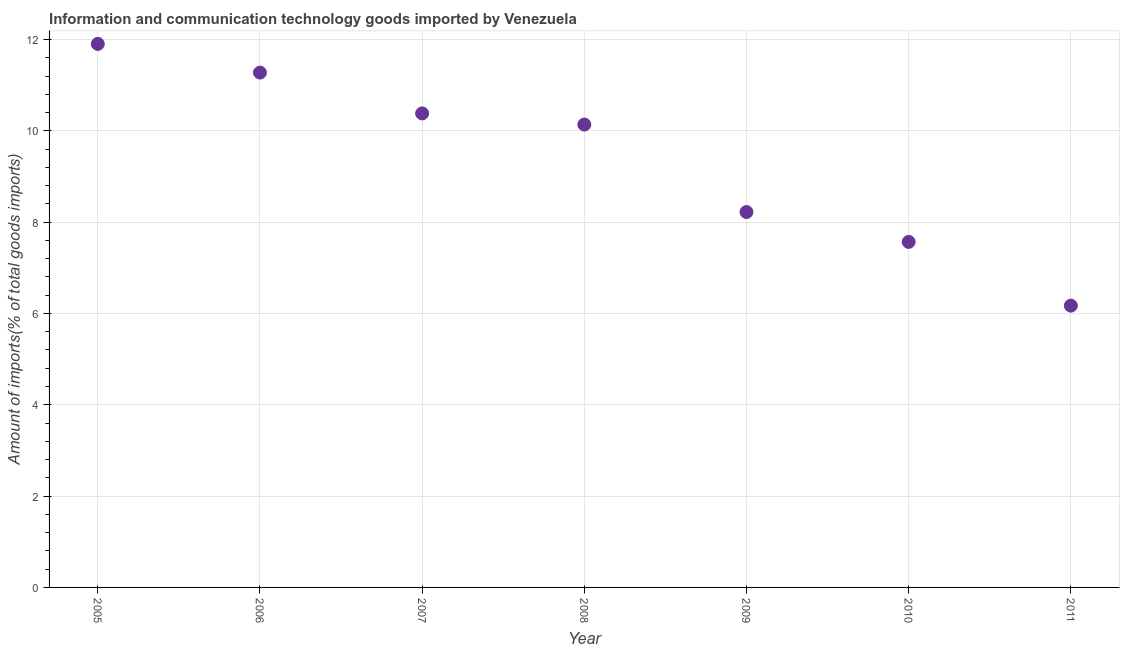What is the amount of ict goods imports in 2011?
Your answer should be compact. 6.17. Across all years, what is the maximum amount of ict goods imports?
Provide a short and direct response. 11.9. Across all years, what is the minimum amount of ict goods imports?
Make the answer very short. 6.17. In which year was the amount of ict goods imports minimum?
Make the answer very short. 2011. What is the sum of the amount of ict goods imports?
Offer a terse response. 65.66. What is the difference between the amount of ict goods imports in 2009 and 2010?
Ensure brevity in your answer.  0.65. What is the average amount of ict goods imports per year?
Offer a terse response. 9.38. What is the median amount of ict goods imports?
Provide a short and direct response. 10.14. In how many years, is the amount of ict goods imports greater than 9.2 %?
Ensure brevity in your answer.  4. Do a majority of the years between 2006 and 2008 (inclusive) have amount of ict goods imports greater than 2.4 %?
Provide a succinct answer. Yes. What is the ratio of the amount of ict goods imports in 2008 to that in 2010?
Offer a very short reply. 1.34. Is the amount of ict goods imports in 2007 less than that in 2010?
Provide a succinct answer. No. What is the difference between the highest and the second highest amount of ict goods imports?
Give a very brief answer. 0.63. What is the difference between the highest and the lowest amount of ict goods imports?
Offer a terse response. 5.73. How many dotlines are there?
Provide a short and direct response. 1. What is the difference between two consecutive major ticks on the Y-axis?
Keep it short and to the point. 2. Does the graph contain any zero values?
Provide a succinct answer. No. What is the title of the graph?
Your answer should be compact. Information and communication technology goods imported by Venezuela. What is the label or title of the Y-axis?
Keep it short and to the point. Amount of imports(% of total goods imports). What is the Amount of imports(% of total goods imports) in 2005?
Offer a terse response. 11.9. What is the Amount of imports(% of total goods imports) in 2006?
Offer a very short reply. 11.28. What is the Amount of imports(% of total goods imports) in 2007?
Your answer should be very brief. 10.38. What is the Amount of imports(% of total goods imports) in 2008?
Your answer should be very brief. 10.14. What is the Amount of imports(% of total goods imports) in 2009?
Offer a terse response. 8.22. What is the Amount of imports(% of total goods imports) in 2010?
Your answer should be very brief. 7.57. What is the Amount of imports(% of total goods imports) in 2011?
Offer a terse response. 6.17. What is the difference between the Amount of imports(% of total goods imports) in 2005 and 2006?
Provide a succinct answer. 0.63. What is the difference between the Amount of imports(% of total goods imports) in 2005 and 2007?
Provide a succinct answer. 1.52. What is the difference between the Amount of imports(% of total goods imports) in 2005 and 2008?
Give a very brief answer. 1.77. What is the difference between the Amount of imports(% of total goods imports) in 2005 and 2009?
Offer a very short reply. 3.68. What is the difference between the Amount of imports(% of total goods imports) in 2005 and 2010?
Your response must be concise. 4.34. What is the difference between the Amount of imports(% of total goods imports) in 2005 and 2011?
Your answer should be very brief. 5.73. What is the difference between the Amount of imports(% of total goods imports) in 2006 and 2007?
Your response must be concise. 0.89. What is the difference between the Amount of imports(% of total goods imports) in 2006 and 2008?
Ensure brevity in your answer.  1.14. What is the difference between the Amount of imports(% of total goods imports) in 2006 and 2009?
Ensure brevity in your answer.  3.05. What is the difference between the Amount of imports(% of total goods imports) in 2006 and 2010?
Offer a terse response. 3.71. What is the difference between the Amount of imports(% of total goods imports) in 2006 and 2011?
Keep it short and to the point. 5.1. What is the difference between the Amount of imports(% of total goods imports) in 2007 and 2008?
Provide a succinct answer. 0.24. What is the difference between the Amount of imports(% of total goods imports) in 2007 and 2009?
Offer a very short reply. 2.16. What is the difference between the Amount of imports(% of total goods imports) in 2007 and 2010?
Your answer should be compact. 2.81. What is the difference between the Amount of imports(% of total goods imports) in 2007 and 2011?
Your answer should be very brief. 4.21. What is the difference between the Amount of imports(% of total goods imports) in 2008 and 2009?
Provide a short and direct response. 1.92. What is the difference between the Amount of imports(% of total goods imports) in 2008 and 2010?
Give a very brief answer. 2.57. What is the difference between the Amount of imports(% of total goods imports) in 2008 and 2011?
Your answer should be compact. 3.97. What is the difference between the Amount of imports(% of total goods imports) in 2009 and 2010?
Provide a succinct answer. 0.65. What is the difference between the Amount of imports(% of total goods imports) in 2009 and 2011?
Your answer should be compact. 2.05. What is the difference between the Amount of imports(% of total goods imports) in 2010 and 2011?
Offer a terse response. 1.4. What is the ratio of the Amount of imports(% of total goods imports) in 2005 to that in 2006?
Provide a short and direct response. 1.06. What is the ratio of the Amount of imports(% of total goods imports) in 2005 to that in 2007?
Give a very brief answer. 1.15. What is the ratio of the Amount of imports(% of total goods imports) in 2005 to that in 2008?
Your answer should be very brief. 1.17. What is the ratio of the Amount of imports(% of total goods imports) in 2005 to that in 2009?
Your answer should be compact. 1.45. What is the ratio of the Amount of imports(% of total goods imports) in 2005 to that in 2010?
Your answer should be very brief. 1.57. What is the ratio of the Amount of imports(% of total goods imports) in 2005 to that in 2011?
Ensure brevity in your answer.  1.93. What is the ratio of the Amount of imports(% of total goods imports) in 2006 to that in 2007?
Offer a terse response. 1.09. What is the ratio of the Amount of imports(% of total goods imports) in 2006 to that in 2008?
Provide a succinct answer. 1.11. What is the ratio of the Amount of imports(% of total goods imports) in 2006 to that in 2009?
Give a very brief answer. 1.37. What is the ratio of the Amount of imports(% of total goods imports) in 2006 to that in 2010?
Offer a terse response. 1.49. What is the ratio of the Amount of imports(% of total goods imports) in 2006 to that in 2011?
Keep it short and to the point. 1.83. What is the ratio of the Amount of imports(% of total goods imports) in 2007 to that in 2009?
Make the answer very short. 1.26. What is the ratio of the Amount of imports(% of total goods imports) in 2007 to that in 2010?
Offer a terse response. 1.37. What is the ratio of the Amount of imports(% of total goods imports) in 2007 to that in 2011?
Offer a very short reply. 1.68. What is the ratio of the Amount of imports(% of total goods imports) in 2008 to that in 2009?
Your answer should be compact. 1.23. What is the ratio of the Amount of imports(% of total goods imports) in 2008 to that in 2010?
Provide a short and direct response. 1.34. What is the ratio of the Amount of imports(% of total goods imports) in 2008 to that in 2011?
Make the answer very short. 1.64. What is the ratio of the Amount of imports(% of total goods imports) in 2009 to that in 2010?
Ensure brevity in your answer.  1.09. What is the ratio of the Amount of imports(% of total goods imports) in 2009 to that in 2011?
Offer a very short reply. 1.33. What is the ratio of the Amount of imports(% of total goods imports) in 2010 to that in 2011?
Your answer should be very brief. 1.23. 